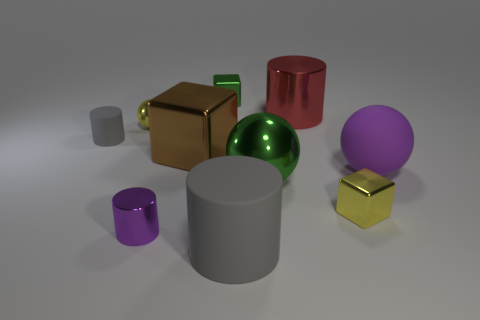Subtract all yellow cylinders. Subtract all cyan cubes. How many cylinders are left? 4 Subtract all cylinders. How many objects are left? 6 Subtract 0 purple cubes. How many objects are left? 10 Subtract all big brown metallic things. Subtract all green things. How many objects are left? 7 Add 5 rubber objects. How many rubber objects are left? 8 Add 8 cyan blocks. How many cyan blocks exist? 8 